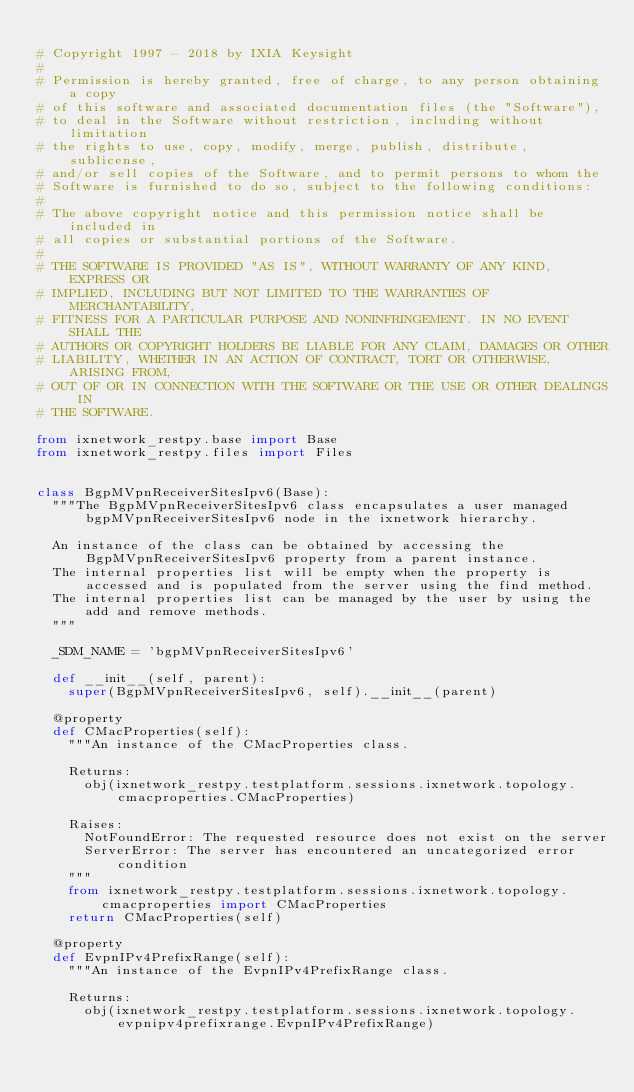<code> <loc_0><loc_0><loc_500><loc_500><_Python_>
# Copyright 1997 - 2018 by IXIA Keysight
#
# Permission is hereby granted, free of charge, to any person obtaining a copy
# of this software and associated documentation files (the "Software"),
# to deal in the Software without restriction, including without limitation
# the rights to use, copy, modify, merge, publish, distribute, sublicense,
# and/or sell copies of the Software, and to permit persons to whom the
# Software is furnished to do so, subject to the following conditions:
#
# The above copyright notice and this permission notice shall be included in
# all copies or substantial portions of the Software.
#
# THE SOFTWARE IS PROVIDED "AS IS", WITHOUT WARRANTY OF ANY KIND, EXPRESS OR
# IMPLIED, INCLUDING BUT NOT LIMITED TO THE WARRANTIES OF MERCHANTABILITY,
# FITNESS FOR A PARTICULAR PURPOSE AND NONINFRINGEMENT. IN NO EVENT SHALL THE
# AUTHORS OR COPYRIGHT HOLDERS BE LIABLE FOR ANY CLAIM, DAMAGES OR OTHER
# LIABILITY, WHETHER IN AN ACTION OF CONTRACT, TORT OR OTHERWISE, ARISING FROM,
# OUT OF OR IN CONNECTION WITH THE SOFTWARE OR THE USE OR OTHER DEALINGS IN
# THE SOFTWARE.
    
from ixnetwork_restpy.base import Base
from ixnetwork_restpy.files import Files


class BgpMVpnReceiverSitesIpv6(Base):
	"""The BgpMVpnReceiverSitesIpv6 class encapsulates a user managed bgpMVpnReceiverSitesIpv6 node in the ixnetwork hierarchy.

	An instance of the class can be obtained by accessing the BgpMVpnReceiverSitesIpv6 property from a parent instance.
	The internal properties list will be empty when the property is accessed and is populated from the server using the find method.
	The internal properties list can be managed by the user by using the add and remove methods.
	"""

	_SDM_NAME = 'bgpMVpnReceiverSitesIpv6'

	def __init__(self, parent):
		super(BgpMVpnReceiverSitesIpv6, self).__init__(parent)

	@property
	def CMacProperties(self):
		"""An instance of the CMacProperties class.

		Returns:
			obj(ixnetwork_restpy.testplatform.sessions.ixnetwork.topology.cmacproperties.CMacProperties)

		Raises:
			NotFoundError: The requested resource does not exist on the server
			ServerError: The server has encountered an uncategorized error condition
		"""
		from ixnetwork_restpy.testplatform.sessions.ixnetwork.topology.cmacproperties import CMacProperties
		return CMacProperties(self)

	@property
	def EvpnIPv4PrefixRange(self):
		"""An instance of the EvpnIPv4PrefixRange class.

		Returns:
			obj(ixnetwork_restpy.testplatform.sessions.ixnetwork.topology.evpnipv4prefixrange.EvpnIPv4PrefixRange)
</code> 